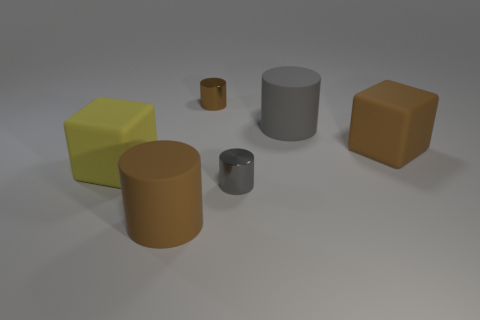What number of things are either tiny metal things that are behind the large gray cylinder or big rubber cubes on the right side of the tiny brown cylinder?
Keep it short and to the point. 2. What number of other objects are there of the same material as the large brown cube?
Provide a short and direct response. 3. Does the small thing that is behind the brown block have the same material as the brown cube?
Make the answer very short. No. Is the number of gray metallic things that are in front of the large yellow matte cube greater than the number of large brown cubes that are to the right of the brown matte block?
Provide a short and direct response. Yes. How many things are large brown things on the right side of the big gray matte thing or tiny brown things?
Offer a terse response. 2. There is a gray object that is made of the same material as the small brown thing; what is its shape?
Your response must be concise. Cylinder. Is there anything else that is the same shape as the small brown object?
Keep it short and to the point. Yes. What color is the object that is both in front of the yellow matte object and on the right side of the large brown cylinder?
Offer a very short reply. Gray. What number of cylinders are tiny gray things or yellow rubber things?
Give a very brief answer. 1. What number of yellow blocks are the same size as the brown block?
Offer a very short reply. 1. 